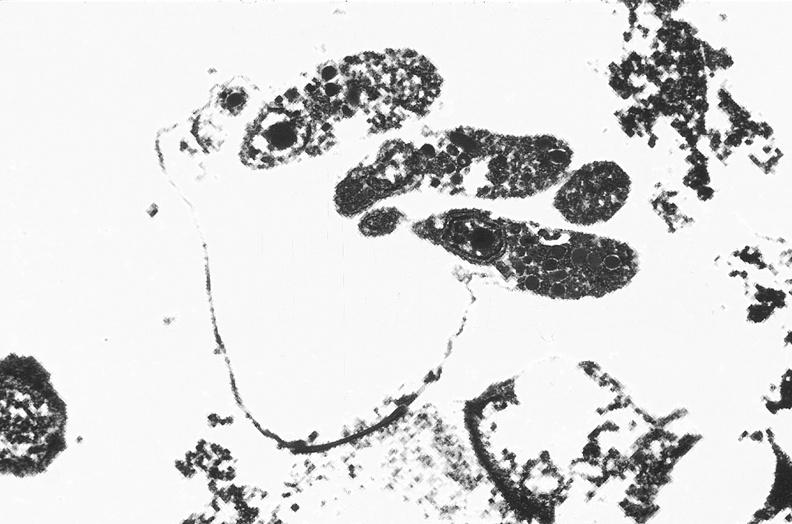s this partially fixed gross present?
Answer the question using a single word or phrase. No 